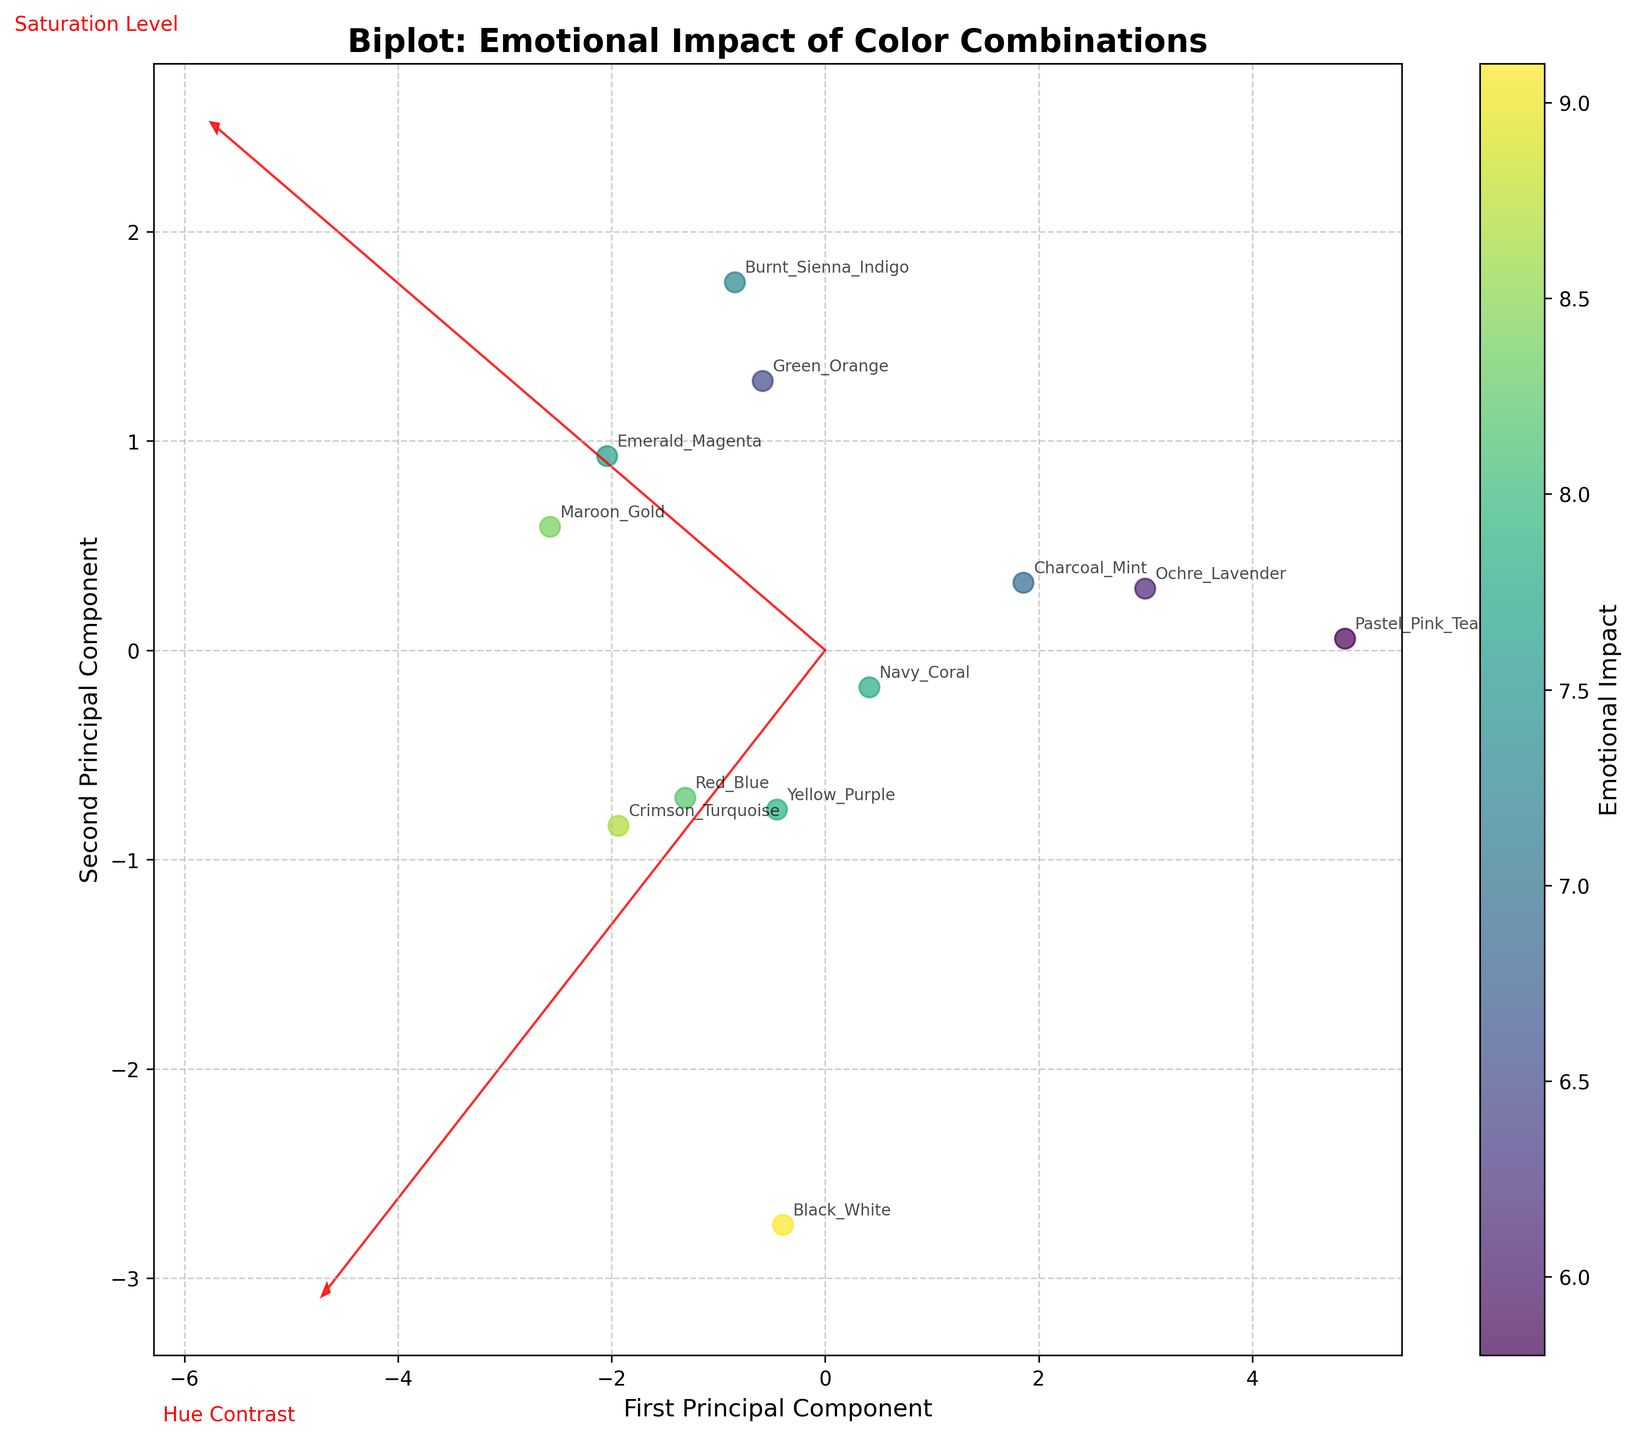What is the title of the plot? The title is displayed at the top of the plot and typically summarizes the data and analysis. The title in this plot is "Biplot: Emotional Impact of Color Combinations."
Answer: Biplot: Emotional Impact of Color Combinations How many color combinations are represented in the plot? To determine the number of color combinations, count the number of unique labels or points on the plot. Each label corresponds to a color combination. There are 12 color combinations labeled in the plot.
Answer: 12 Which color combination has the highest emotional impact? To find the color combination with the highest emotional impact, look at the colorbar and identify the point that corresponds to the highest value. The color combination "Black_White" has the highest emotional impact of 9.1.
Answer: Black_White Where is the "Red_Blue" color combination positioned in terms of the principal components? Locate the "Red_Blue" label on the plot and read the values of the first and second principal components at that point. The "Red_Blue" combination is positioned at approximately (0.62, 2.0).
Answer: (0.62, 2.0) Which axis represents the first principal component? The x-axis represents the first principal component, as indicated by the xlabel "First Principal Component."
Answer: x-axis Which feature, "Hue Contrast" or "Saturation Level," contributes more to the first principal component? Observe the arrows representing the features. The length of the arrow for "Hue Contrast" along the x-axis (first principal component) is longer than that for "Saturation Level," indicating "Hue Contrast" contributes more.
Answer: Hue Contrast How does the "Crimson_Turquoise" combination compare to the "Maroon_Gold" combination in terms of emotional impact? Compare the colors of the points for "Crimson_Turquoise" and "Maroon_Gold" using the colorbar scale. "Crimson_Turquoise" has an emotional impact of 8.7, while "Maroon_Gold" has 8.4, so "Crimson_Turquoise" has a slightly higher emotional impact.
Answer: Crimson_Turquoise has higher emotional impact What is the relationship between "Hue Contrast" and "Saturation Level" in determining emotional impact? By observing the direction and length of the feature vectors, "Hue Contrast" has a stronger influence on the first principal component and "Saturation Level" on the second. Points with high emotional impact are distributed along both components, indicating both features significantly affect emotional impact.
Answer: Both features significantly influence emotional impact How close are "Yellow_Purple" and "Navy_Coral" on the plot? By looking at the plot, "Yellow_Purple" and "Navy_Coral" are placed closely to each other along the principal components’ axes, depicting they have similar contributions from "Hue Contrast" and "Saturation Level."
Answer: Close Which feature (Hue Contrast or Saturation Level) has a more pronounced influence on the spread of data points? By analyzing the dimensions of the spread formed by the points along the principal components, the feature vector for "Hue Contrast" appears to have a more extended spread, indicating it has a more pronounced influence on the data point distribution.
Answer: Hue Contrast 